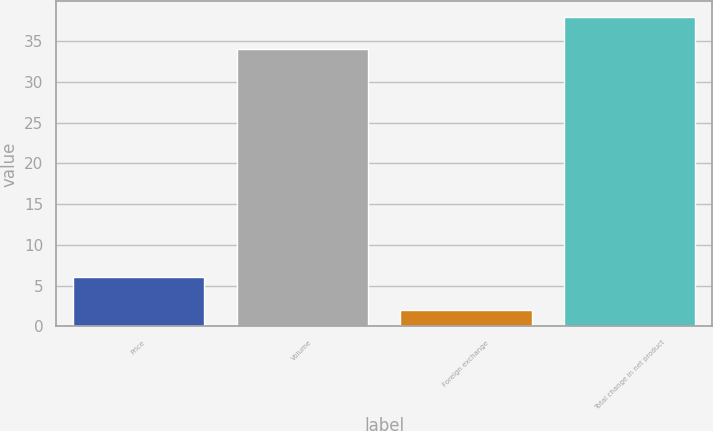Convert chart to OTSL. <chart><loc_0><loc_0><loc_500><loc_500><bar_chart><fcel>Price<fcel>Volume<fcel>Foreign exchange<fcel>Total change in net product<nl><fcel>6<fcel>34<fcel>2<fcel>38<nl></chart> 